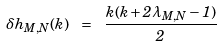<formula> <loc_0><loc_0><loc_500><loc_500>\delta h _ { M , N } ( k ) \ = \ \frac { k ( k + 2 \lambda _ { M , N } - 1 ) } { 2 }</formula> 